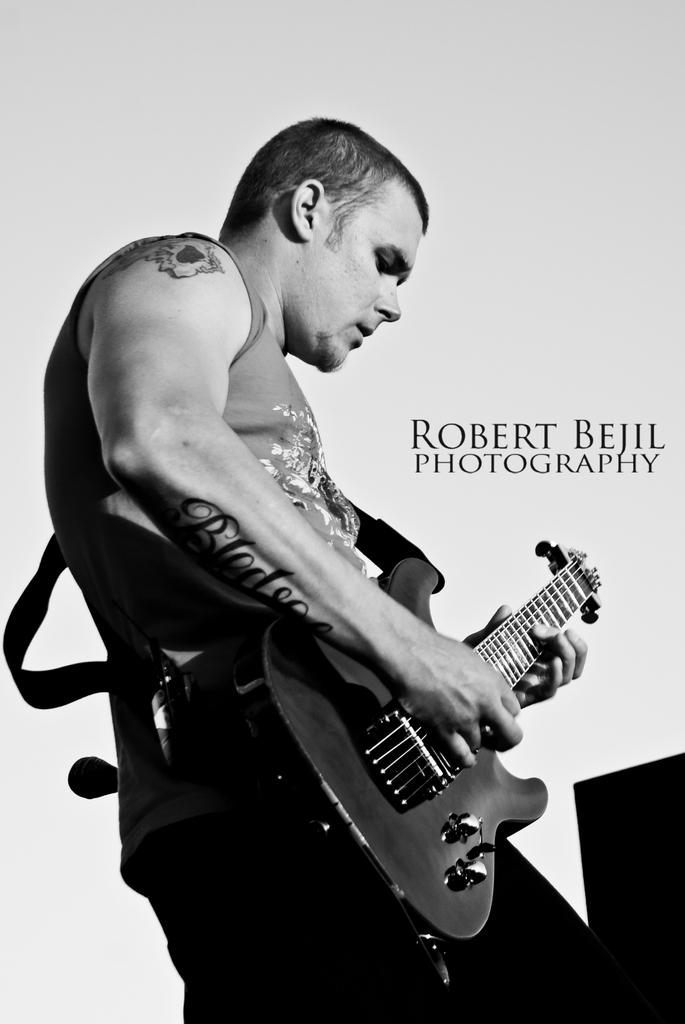What is the main subject of the image? The main subject of the image is a man. What is the man doing in the image? The man is standing and playing a guitar. What type of bridge can be seen in the background of the image? There is no bridge present in the image; it only features a man standing and playing a guitar. 